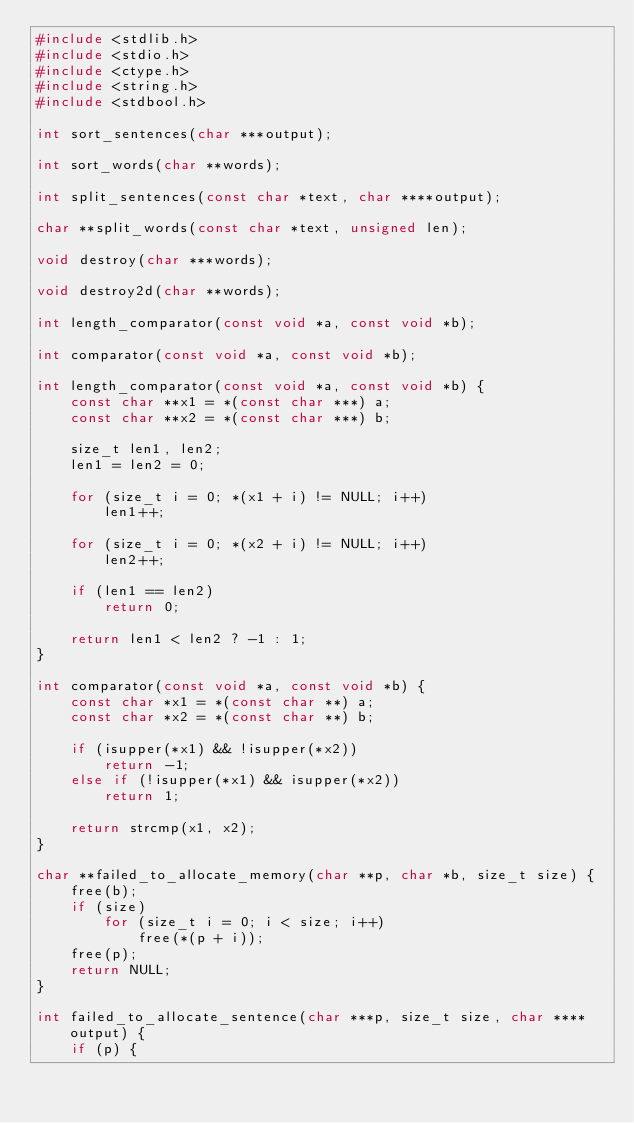<code> <loc_0><loc_0><loc_500><loc_500><_C_>#include <stdlib.h>
#include <stdio.h>
#include <ctype.h>
#include <string.h>
#include <stdbool.h>

int sort_sentences(char ***output);

int sort_words(char **words);

int split_sentences(const char *text, char ****output);

char **split_words(const char *text, unsigned len);

void destroy(char ***words);

void destroy2d(char **words);

int length_comparator(const void *a, const void *b);

int comparator(const void *a, const void *b);

int length_comparator(const void *a, const void *b) {
    const char **x1 = *(const char ***) a;
    const char **x2 = *(const char ***) b;

    size_t len1, len2;
    len1 = len2 = 0;

    for (size_t i = 0; *(x1 + i) != NULL; i++)
        len1++;

    for (size_t i = 0; *(x2 + i) != NULL; i++)
        len2++;

    if (len1 == len2)
        return 0;

    return len1 < len2 ? -1 : 1;
}

int comparator(const void *a, const void *b) {
    const char *x1 = *(const char **) a;
    const char *x2 = *(const char **) b;

    if (isupper(*x1) && !isupper(*x2))
        return -1;
    else if (!isupper(*x1) && isupper(*x2))
        return 1;

    return strcmp(x1, x2);
}

char **failed_to_allocate_memory(char **p, char *b, size_t size) {
    free(b);
    if (size)
        for (size_t i = 0; i < size; i++)
            free(*(p + i));
    free(p);
    return NULL;
}

int failed_to_allocate_sentence(char ***p, size_t size, char ****output) {
    if (p) {</code> 